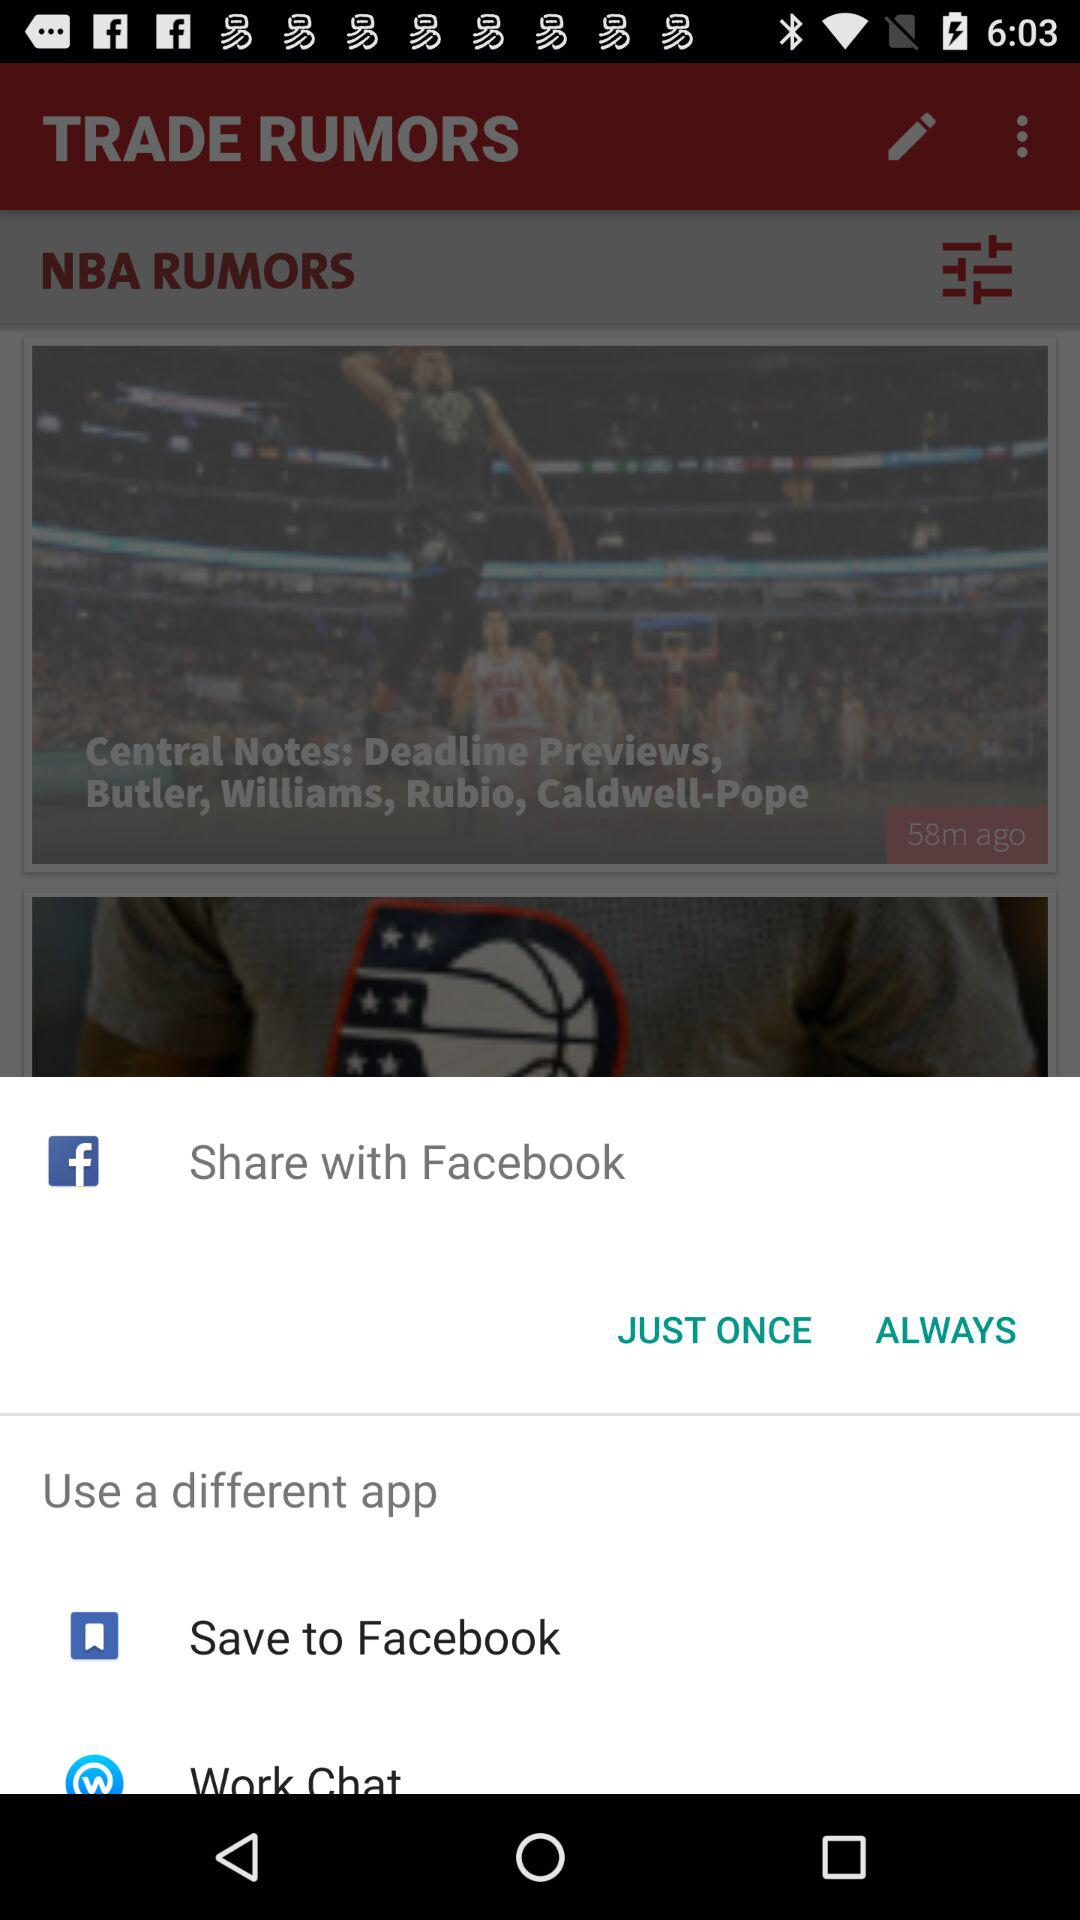Who is this application powered by?
When the provided information is insufficient, respond with <no answer>. <no answer> 